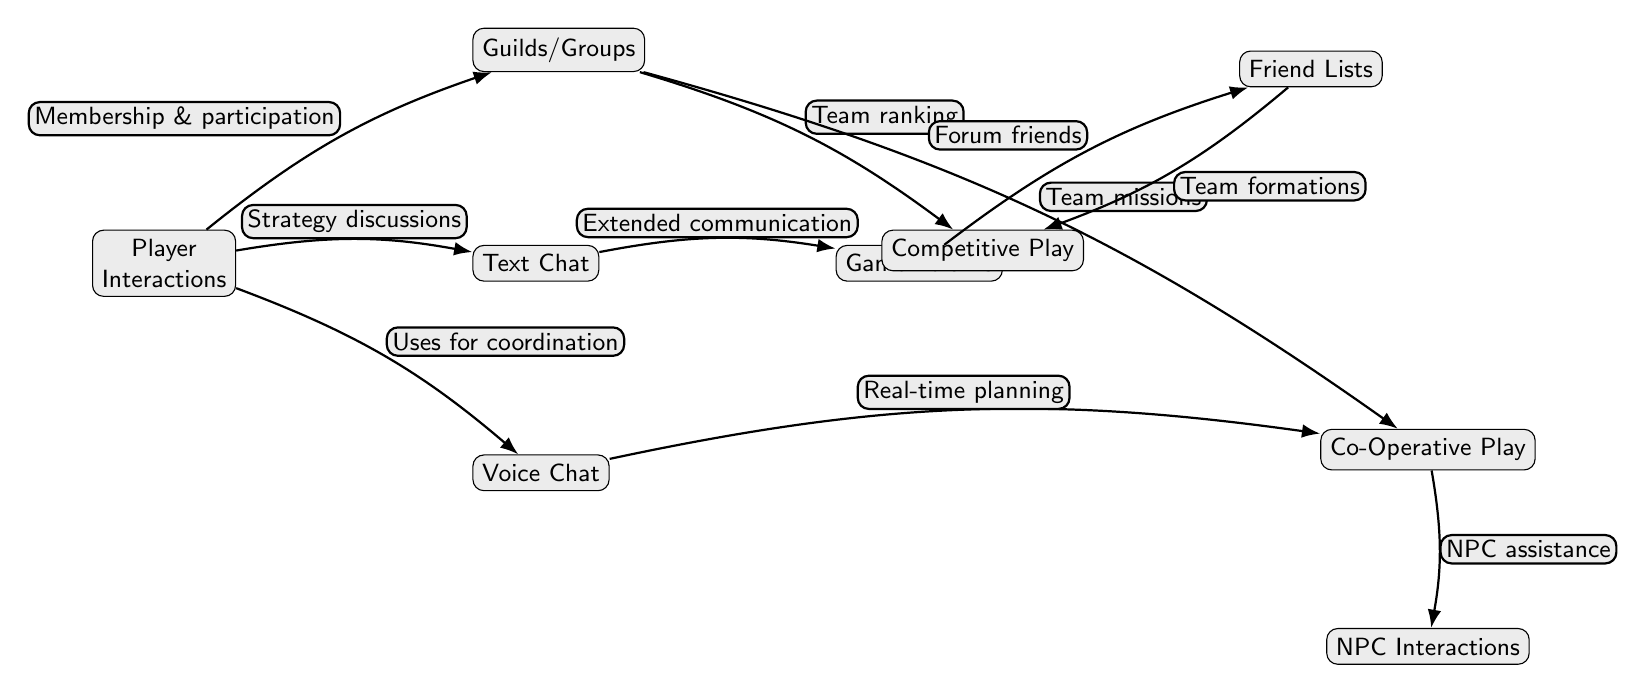What is the central node of the diagram? The central node in the diagram is "Player Interactions," as it is positioned centrally among the other nodes, indicating its primary role in the social dynamics of multiplayer games.
Answer: Player Interactions How many nodes are represented in the diagram? The diagram features a total of nine distinct nodes, each representing a different aspect of social dynamics in multiplayer gaming.
Answer: Nine What type of communication does the "Voice Chat" node primarily facilitate? The "Voice Chat" node primarily facilitates "Real-time planning," as indicated by the directed edge connecting it to the "Co-Operative Play" node.
Answer: Real-time planning What is the relationship between "Guilds/Groups" and "Competitive Play"? The relationship is characterized by "Team ranking," which is the labeled edge connecting "Guilds/Groups" to "Competitive Play" in the diagram.
Answer: Team ranking How does "Text Chat" extend communication according to the diagram? "Text Chat" extends communication through "Extended communication," which is the connection from "Text Chat" to "Game Forums." This indicates how text chat enables further discussions that can lead to forum interactions.
Answer: Extended communication Which node directly influences NPC Interactions? The node that directly influences "NPC Interactions" is "Co-Operative Play," as shown by the edge labeled "NPC assistance" connecting these two nodes in the diagram.
Answer: Co-Operative Play What is indicated by the connection from "Friend Lists" to "Competitive Play"? The connection from "Friend Lists" to "Competitive Play" implies that "Team formations" are formed based on friendships, as depicted by the edge label linking these nodes together.
Answer: Team formations What type of interactions come after "Team missions"? Following "Team missions," the next type of interaction illustrated is "Co-Operative Play," as indicated by the edge from "Guilds/Groups" to "Co-Operative Play."
Answer: Co-Operative Play What type of play is connected to "NPC Interactions"? The type of play connected to "NPC Interactions" is "Co-Operative Play," indicated by the directed edge that leads from "Co-Operative Play" to "NPC Interactions" in the diagram.
Answer: Co-Operative Play 